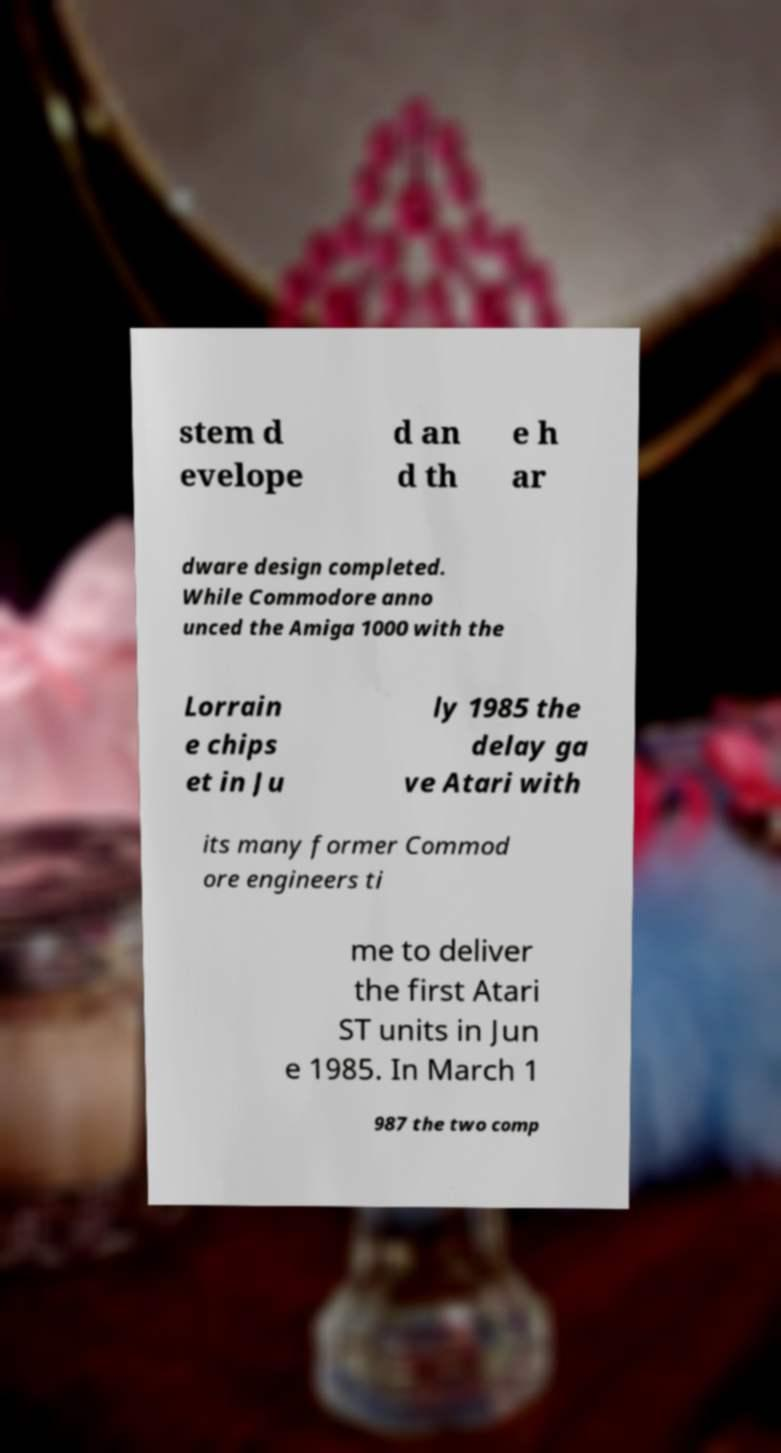Could you extract and type out the text from this image? stem d evelope d an d th e h ar dware design completed. While Commodore anno unced the Amiga 1000 with the Lorrain e chips et in Ju ly 1985 the delay ga ve Atari with its many former Commod ore engineers ti me to deliver the first Atari ST units in Jun e 1985. In March 1 987 the two comp 